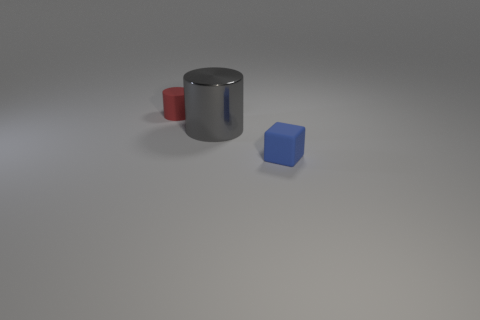Add 2 metallic things. How many objects exist? 5 Subtract all red cylinders. How many cylinders are left? 1 Subtract all cylinders. How many objects are left? 1 Add 2 big red matte spheres. How many big red matte spheres exist? 2 Subtract 1 blue blocks. How many objects are left? 2 Subtract all brown blocks. Subtract all blue spheres. How many blocks are left? 1 Subtract all big yellow metallic cylinders. Subtract all blue things. How many objects are left? 2 Add 1 small rubber things. How many small rubber things are left? 3 